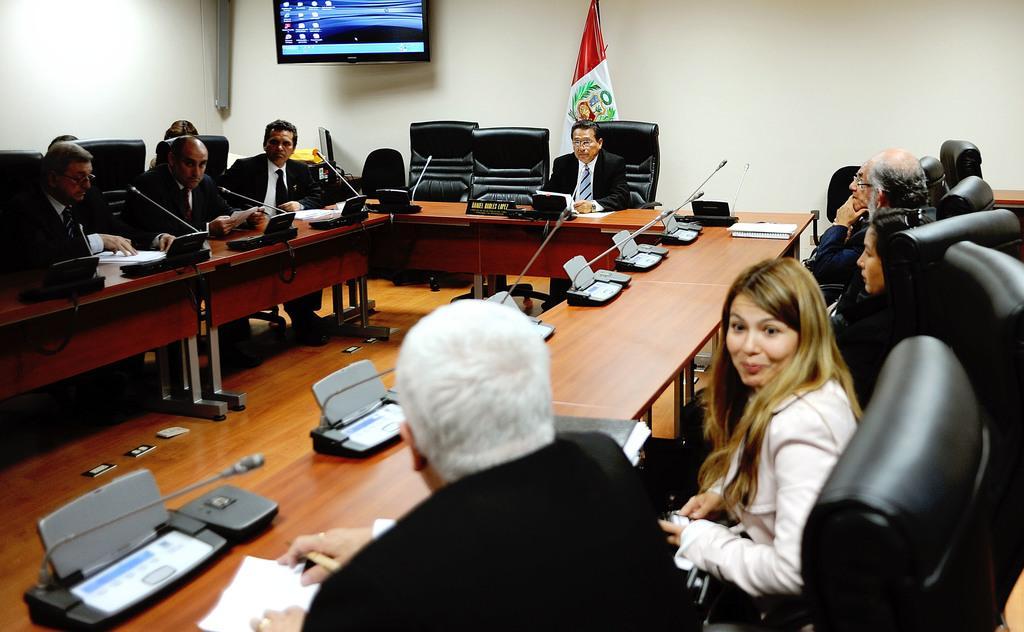Can you describe this image briefly? This is the inside view of a conference room. Here we can see so many people sitting on the chair around the table. And on the table there are some microphones. Here we can see a person who is sitting and holding a pen and besides him a woman is sitting and smiling. And on the background there is a wall and we can see a flag here. Here there is a screen and this is the floor. 